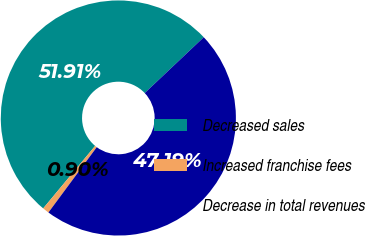<chart> <loc_0><loc_0><loc_500><loc_500><pie_chart><fcel>Decreased sales<fcel>Increased franchise fees<fcel>Decrease in total revenues<nl><fcel>51.91%<fcel>0.9%<fcel>47.19%<nl></chart> 